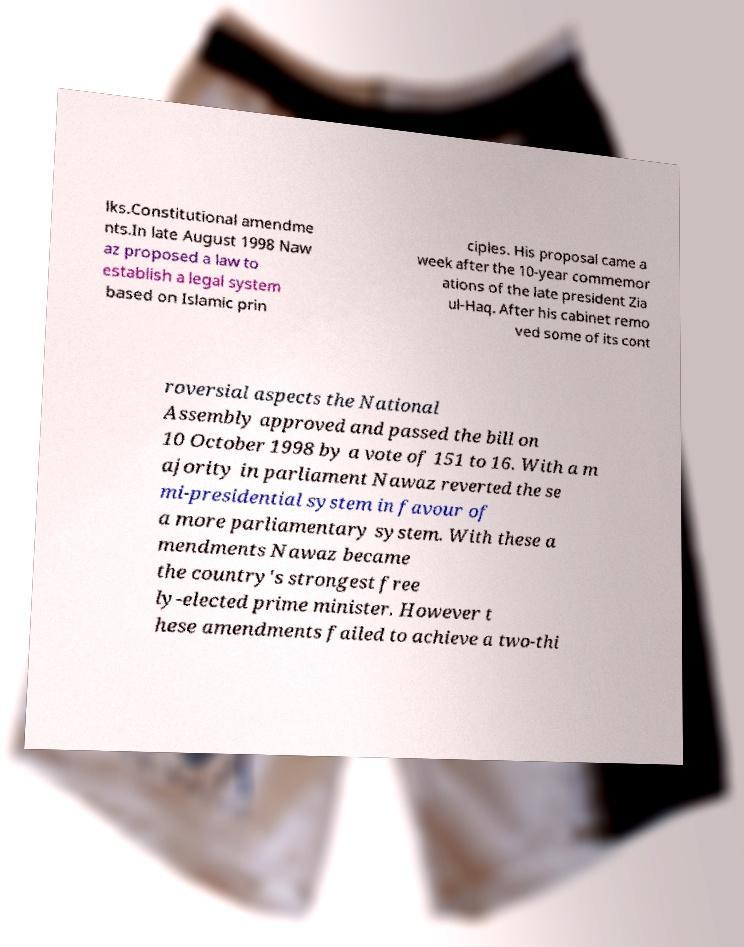For documentation purposes, I need the text within this image transcribed. Could you provide that? lks.Constitutional amendme nts.In late August 1998 Naw az proposed a law to establish a legal system based on Islamic prin ciples. His proposal came a week after the 10-year commemor ations of the late president Zia ul-Haq. After his cabinet remo ved some of its cont roversial aspects the National Assembly approved and passed the bill on 10 October 1998 by a vote of 151 to 16. With a m ajority in parliament Nawaz reverted the se mi-presidential system in favour of a more parliamentary system. With these a mendments Nawaz became the country's strongest free ly-elected prime minister. However t hese amendments failed to achieve a two-thi 